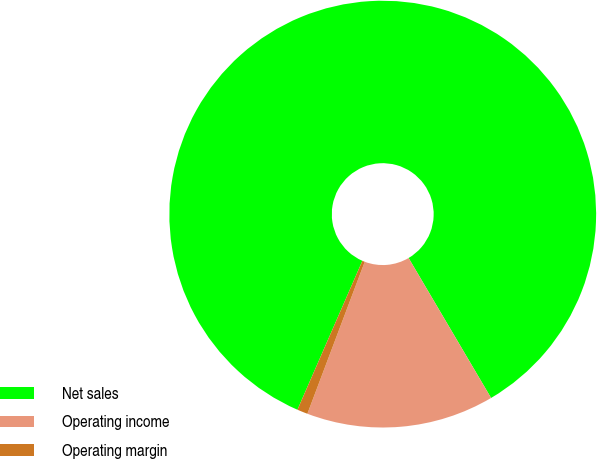<chart> <loc_0><loc_0><loc_500><loc_500><pie_chart><fcel>Net sales<fcel>Operating income<fcel>Operating margin<nl><fcel>84.98%<fcel>14.22%<fcel>0.8%<nl></chart> 